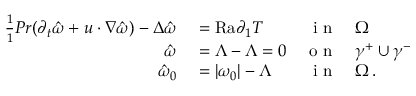Convert formula to latex. <formula><loc_0><loc_0><loc_500><loc_500>\begin{array} { r l r l } { \frac { 1 } { 1 } { P r } ( \partial _ { t } \hat { \omega } + u \cdot \nabla \hat { \omega } ) - \Delta \hat { \omega } } & = { R a } \partial _ { 1 } T } & { i n } & \Omega } \\ { \hat { \omega } } & = \Lambda - \Lambda = 0 } & { o n } & \gamma ^ { + } \cup \gamma ^ { - } } \\ { \hat { \omega } _ { 0 } } & = | \omega _ { 0 } | - \Lambda } & { i n } & \Omega \, . } \end{array}</formula> 